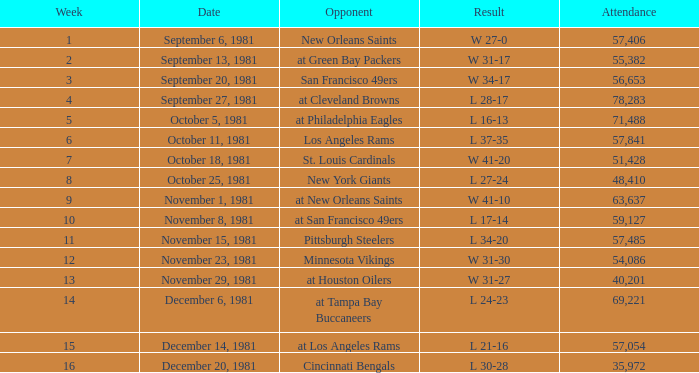What was the average number of attendance for the game on November 29, 1981 played after week 13? None. 